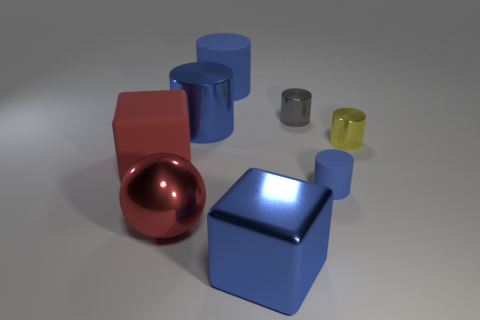Is there anything else that is the same shape as the red shiny object?
Give a very brief answer. No. There is a gray object that is the same shape as the small blue rubber thing; what material is it?
Keep it short and to the point. Metal. Is there any other thing that is the same size as the blue metal cylinder?
Make the answer very short. Yes. What shape is the big rubber thing in front of the gray thing?
Ensure brevity in your answer.  Cube. How many other rubber things have the same shape as the tiny blue rubber thing?
Offer a terse response. 1. Are there the same number of blue cubes behind the matte block and blue matte cylinders to the right of the small blue thing?
Provide a short and direct response. Yes. Is there a big blue cylinder made of the same material as the sphere?
Make the answer very short. Yes. Is the tiny blue cylinder made of the same material as the small gray object?
Your answer should be very brief. No. What number of red things are small spheres or blocks?
Provide a short and direct response. 1. Is the number of tiny yellow metallic objects that are in front of the large red rubber block greater than the number of small red metal cylinders?
Make the answer very short. No. 